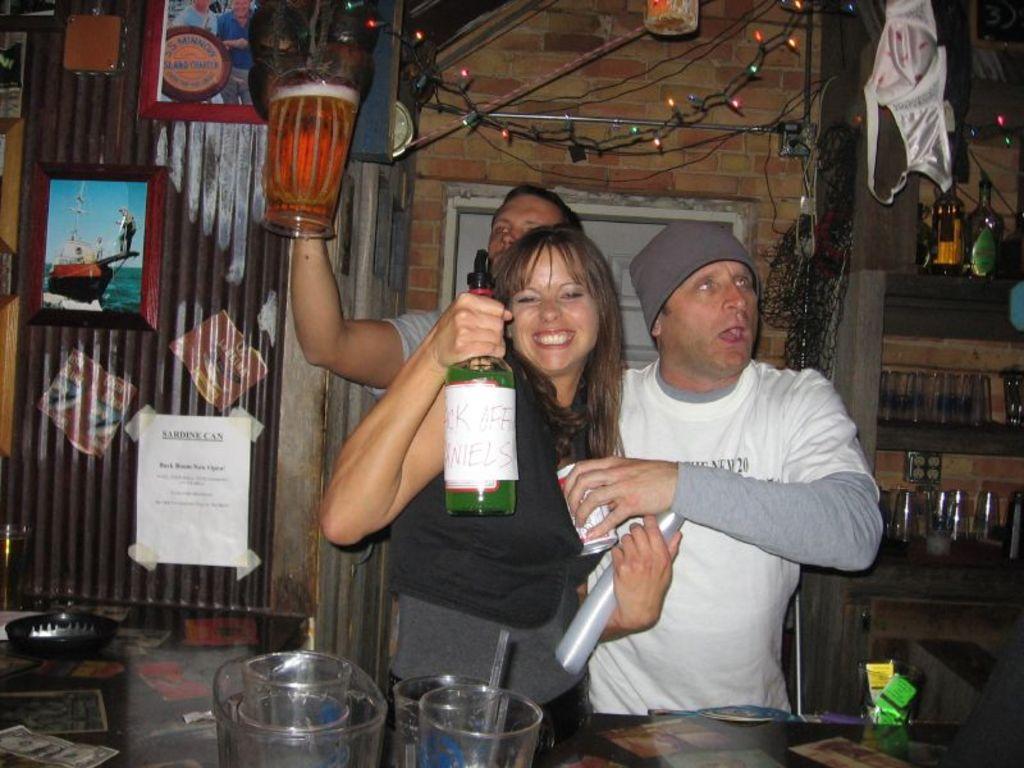In one or two sentences, can you explain what this image depicts? In this image I can see three persons standing. In front the person is wearing black and grey color dress and holding the bottle, background I can see few frames and papers attached to the brown color surface and I can also see few lights in multi color. 